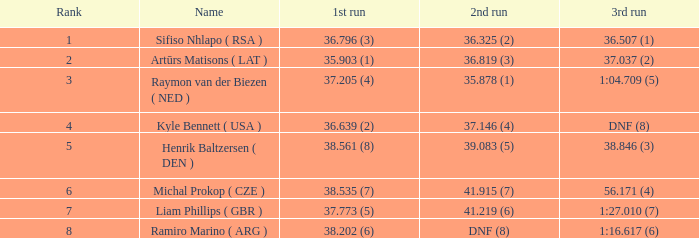What is the average rank that has a sum of 16? 5.0. 